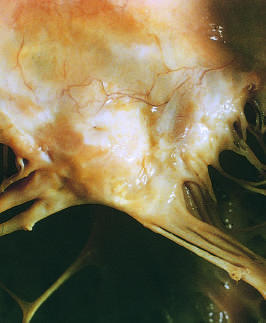s there marked left atrial dilation as seen from above the valve?
Answer the question using a single word or phrase. Yes 